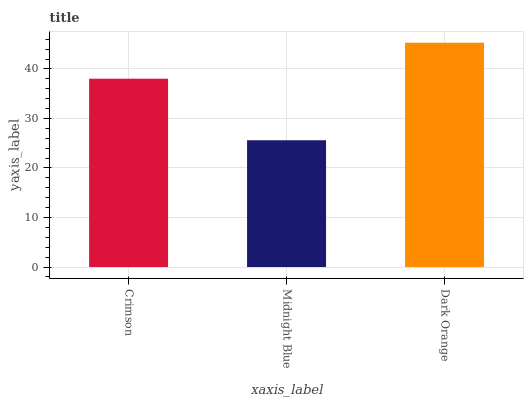Is Dark Orange the minimum?
Answer yes or no. No. Is Midnight Blue the maximum?
Answer yes or no. No. Is Dark Orange greater than Midnight Blue?
Answer yes or no. Yes. Is Midnight Blue less than Dark Orange?
Answer yes or no. Yes. Is Midnight Blue greater than Dark Orange?
Answer yes or no. No. Is Dark Orange less than Midnight Blue?
Answer yes or no. No. Is Crimson the high median?
Answer yes or no. Yes. Is Crimson the low median?
Answer yes or no. Yes. Is Midnight Blue the high median?
Answer yes or no. No. Is Dark Orange the low median?
Answer yes or no. No. 